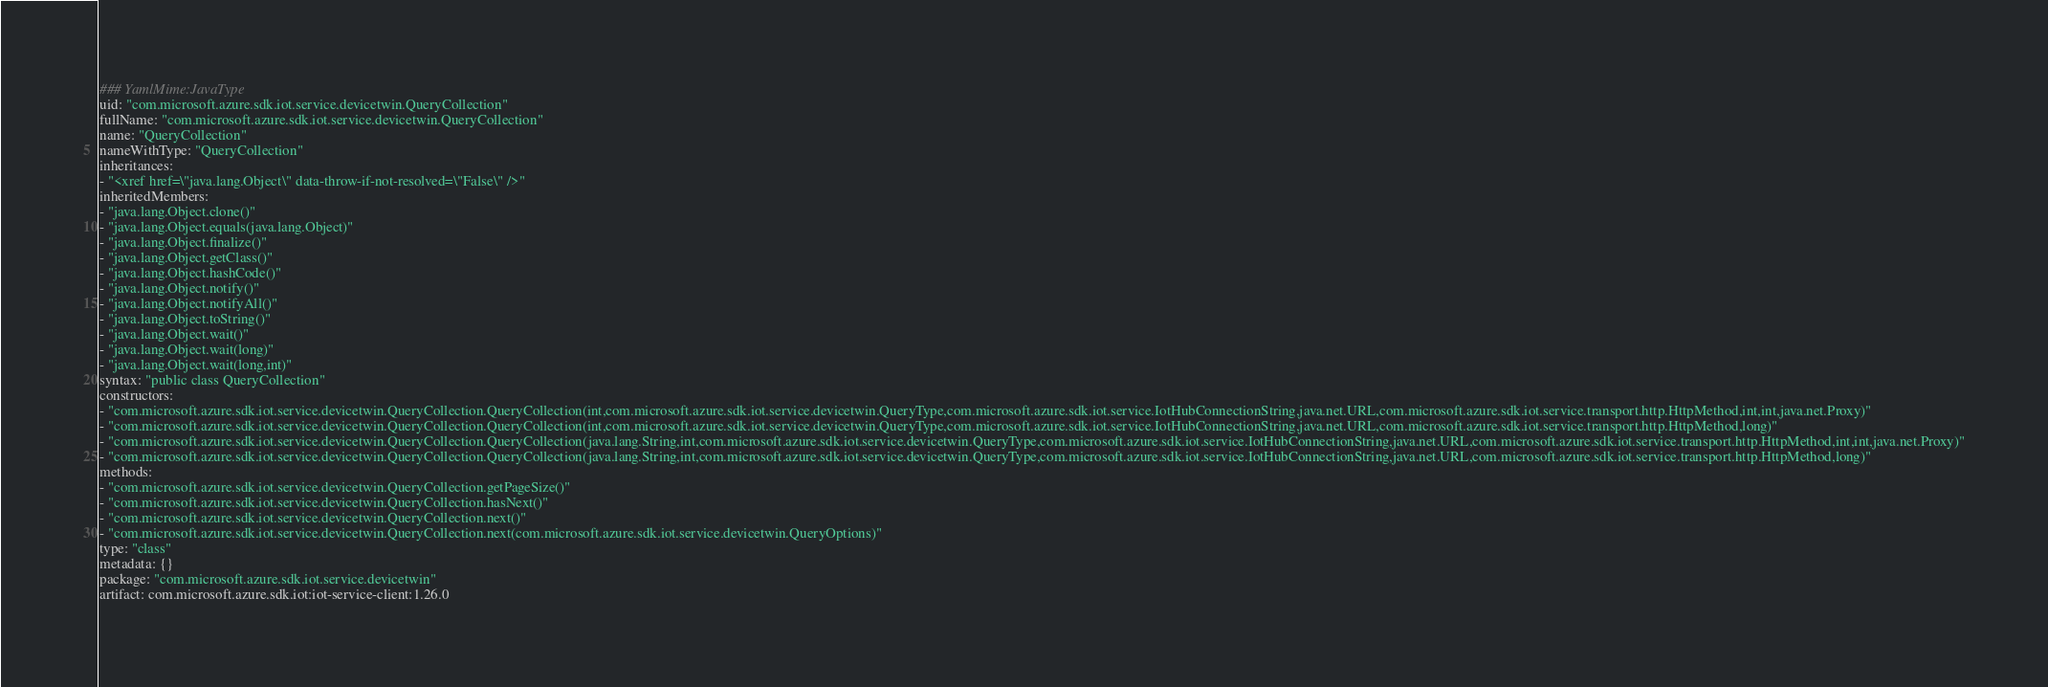Convert code to text. <code><loc_0><loc_0><loc_500><loc_500><_YAML_>### YamlMime:JavaType
uid: "com.microsoft.azure.sdk.iot.service.devicetwin.QueryCollection"
fullName: "com.microsoft.azure.sdk.iot.service.devicetwin.QueryCollection"
name: "QueryCollection"
nameWithType: "QueryCollection"
inheritances:
- "<xref href=\"java.lang.Object\" data-throw-if-not-resolved=\"False\" />"
inheritedMembers:
- "java.lang.Object.clone()"
- "java.lang.Object.equals(java.lang.Object)"
- "java.lang.Object.finalize()"
- "java.lang.Object.getClass()"
- "java.lang.Object.hashCode()"
- "java.lang.Object.notify()"
- "java.lang.Object.notifyAll()"
- "java.lang.Object.toString()"
- "java.lang.Object.wait()"
- "java.lang.Object.wait(long)"
- "java.lang.Object.wait(long,int)"
syntax: "public class QueryCollection"
constructors:
- "com.microsoft.azure.sdk.iot.service.devicetwin.QueryCollection.QueryCollection(int,com.microsoft.azure.sdk.iot.service.devicetwin.QueryType,com.microsoft.azure.sdk.iot.service.IotHubConnectionString,java.net.URL,com.microsoft.azure.sdk.iot.service.transport.http.HttpMethod,int,int,java.net.Proxy)"
- "com.microsoft.azure.sdk.iot.service.devicetwin.QueryCollection.QueryCollection(int,com.microsoft.azure.sdk.iot.service.devicetwin.QueryType,com.microsoft.azure.sdk.iot.service.IotHubConnectionString,java.net.URL,com.microsoft.azure.sdk.iot.service.transport.http.HttpMethod,long)"
- "com.microsoft.azure.sdk.iot.service.devicetwin.QueryCollection.QueryCollection(java.lang.String,int,com.microsoft.azure.sdk.iot.service.devicetwin.QueryType,com.microsoft.azure.sdk.iot.service.IotHubConnectionString,java.net.URL,com.microsoft.azure.sdk.iot.service.transport.http.HttpMethod,int,int,java.net.Proxy)"
- "com.microsoft.azure.sdk.iot.service.devicetwin.QueryCollection.QueryCollection(java.lang.String,int,com.microsoft.azure.sdk.iot.service.devicetwin.QueryType,com.microsoft.azure.sdk.iot.service.IotHubConnectionString,java.net.URL,com.microsoft.azure.sdk.iot.service.transport.http.HttpMethod,long)"
methods:
- "com.microsoft.azure.sdk.iot.service.devicetwin.QueryCollection.getPageSize()"
- "com.microsoft.azure.sdk.iot.service.devicetwin.QueryCollection.hasNext()"
- "com.microsoft.azure.sdk.iot.service.devicetwin.QueryCollection.next()"
- "com.microsoft.azure.sdk.iot.service.devicetwin.QueryCollection.next(com.microsoft.azure.sdk.iot.service.devicetwin.QueryOptions)"
type: "class"
metadata: {}
package: "com.microsoft.azure.sdk.iot.service.devicetwin"
artifact: com.microsoft.azure.sdk.iot:iot-service-client:1.26.0
</code> 